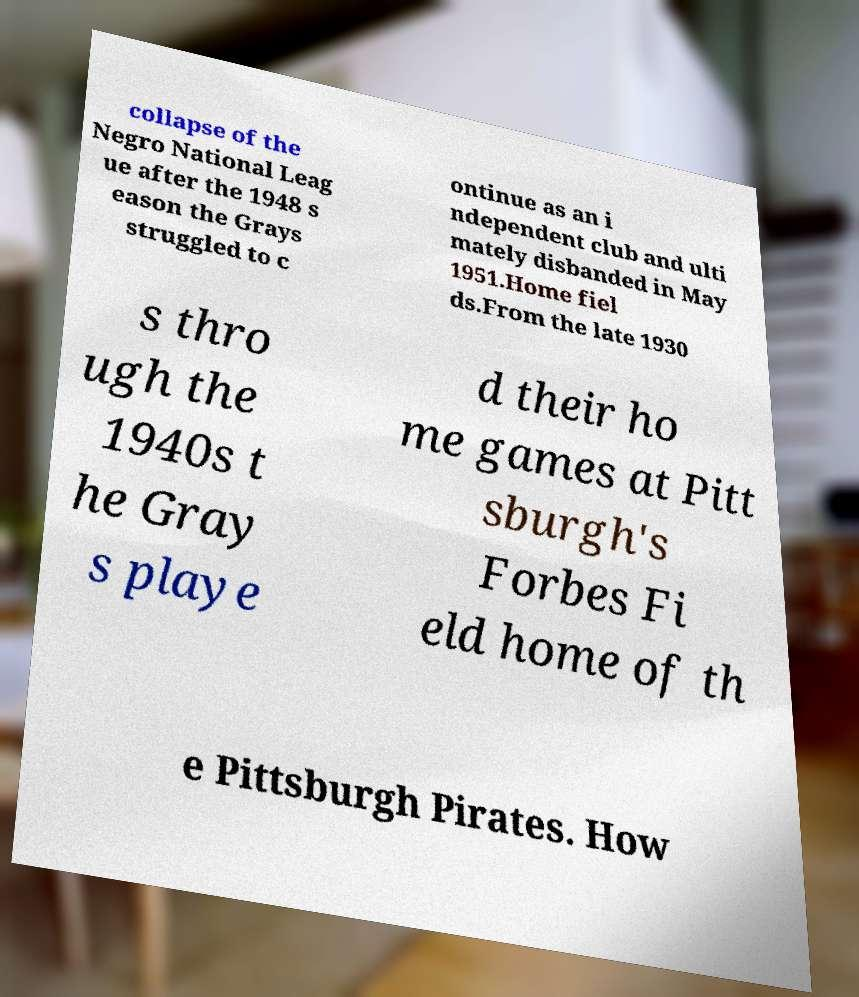What messages or text are displayed in this image? I need them in a readable, typed format. collapse of the Negro National Leag ue after the 1948 s eason the Grays struggled to c ontinue as an i ndependent club and ulti mately disbanded in May 1951.Home fiel ds.From the late 1930 s thro ugh the 1940s t he Gray s playe d their ho me games at Pitt sburgh's Forbes Fi eld home of th e Pittsburgh Pirates. How 